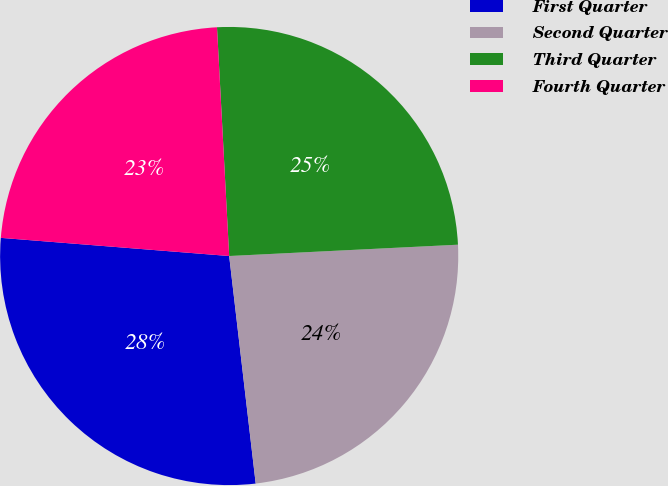Convert chart to OTSL. <chart><loc_0><loc_0><loc_500><loc_500><pie_chart><fcel>First Quarter<fcel>Second Quarter<fcel>Third Quarter<fcel>Fourth Quarter<nl><fcel>28.11%<fcel>23.94%<fcel>25.06%<fcel>22.89%<nl></chart> 